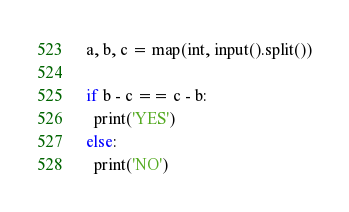<code> <loc_0><loc_0><loc_500><loc_500><_Python_>a, b, c = map(int, input().split())

if b - c == c - b:
  print('YES')
else:
  print('NO')</code> 